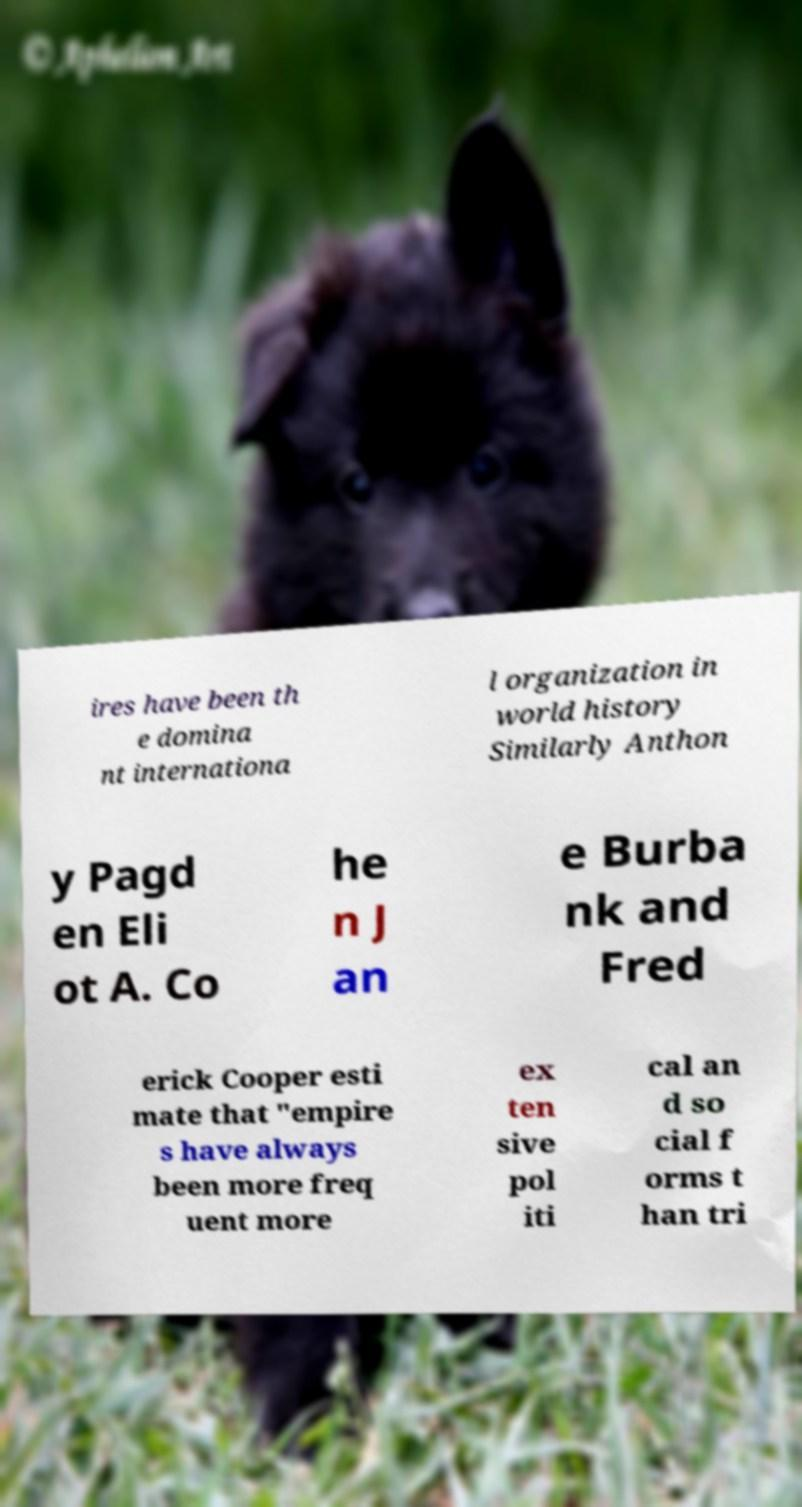Can you read and provide the text displayed in the image?This photo seems to have some interesting text. Can you extract and type it out for me? ires have been th e domina nt internationa l organization in world history Similarly Anthon y Pagd en Eli ot A. Co he n J an e Burba nk and Fred erick Cooper esti mate that "empire s have always been more freq uent more ex ten sive pol iti cal an d so cial f orms t han tri 